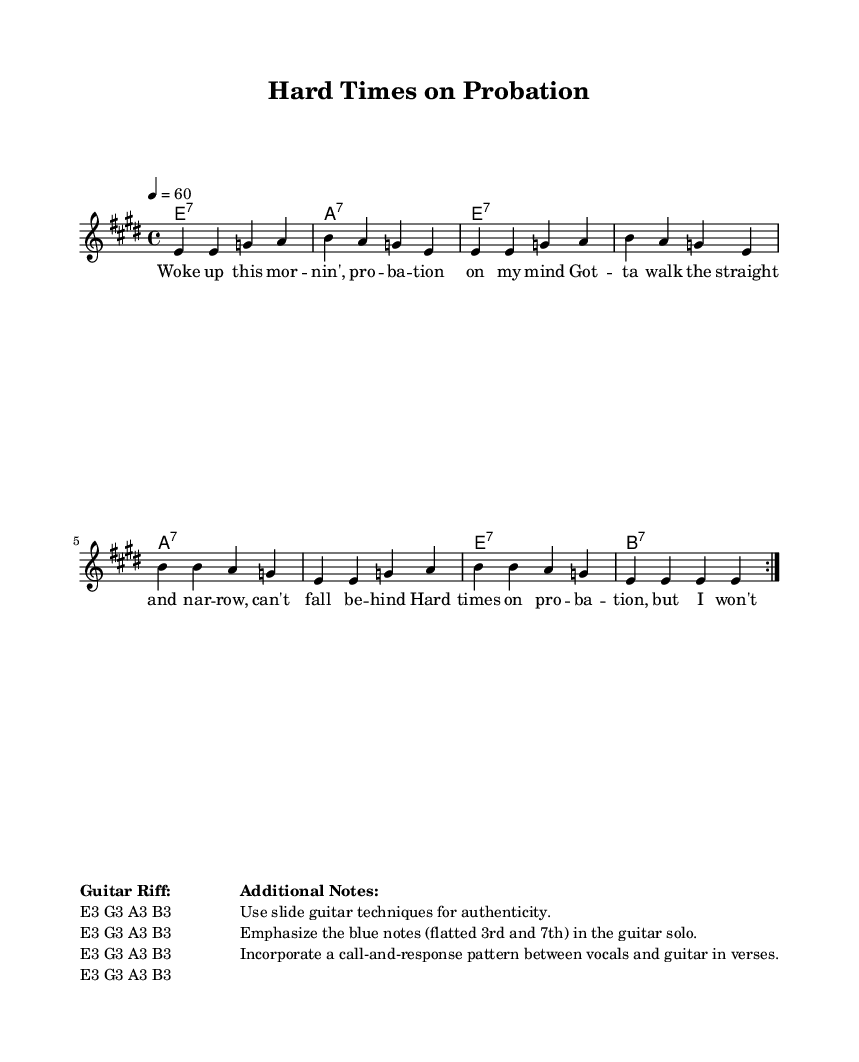What is the key signature of this music? The key signature is indicated by the notes that are present in the music, specifically any sharps or flats that appear at the beginning of the staff. Here, there is one sharp (C#) which corresponds to E major.
Answer: E major What is the time signature of this piece? The time signature is shown at the beginning of the sheet music, represented by the numbers that sit right after the key signature. In this case, it is 4 over 4, indicating four beats per measure.
Answer: 4/4 What is the tempo marking for this music? The tempo is provided at the beginning of the piece, indicated by a number value followed by the equals sign and a note value. Here, it states 4 equals 60, meaning each quarter note gets 60 beats per minute.
Answer: 60 How many measures are in the first section before the repeat? To determine the number of measures, we count the individual sections from the start to the repeat indication. There are 8 measures in the first section.
Answer: 8 What chord is played at measure 1? The chord is noted at the beginning of the staff, and one can see that the chord at measure 1 is stated as E7. This is indicated directly under the staff at that point.
Answer: E7 What is a unique feature of the Blues genre reflected in this music? The music employs a call-and-response structure, which is a fundamental characteristic of Blues genres. This is especially noted during the vocal and guitar interplay in verses, typical of this style.
Answer: Call-and-response Which note should be emphasized in the guitar solo? The additional notes section specifies the notes that should be emphasized in the guitar solo, explicitly mentioning the blue notes, which are the flatted third and seventh, reflecting the genre's characteristic sound.
Answer: Blue notes 